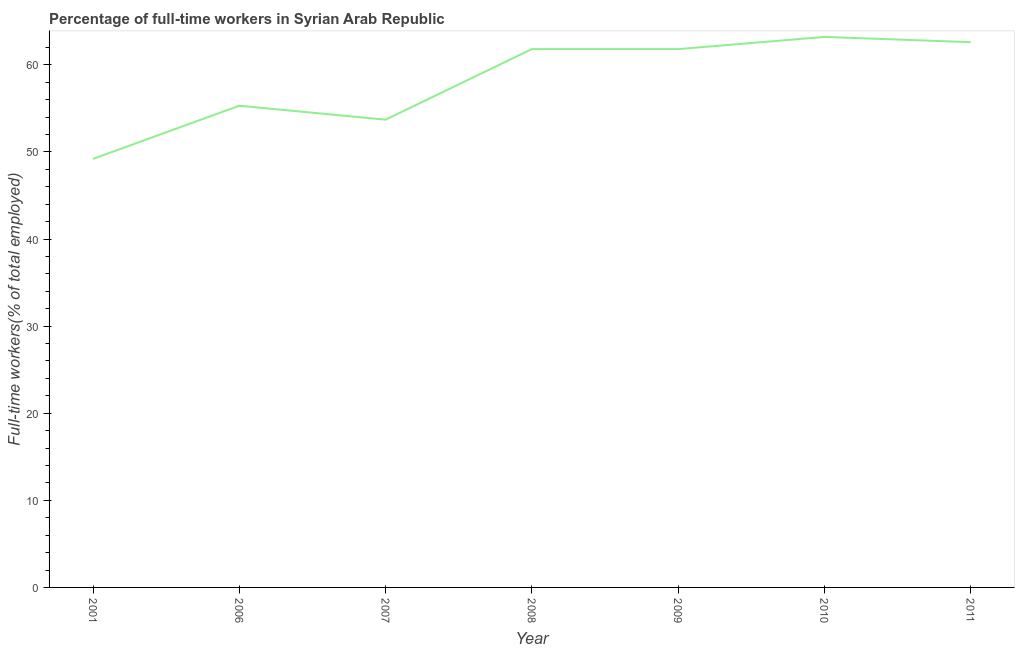What is the percentage of full-time workers in 2006?
Your response must be concise. 55.3. Across all years, what is the maximum percentage of full-time workers?
Your answer should be very brief. 63.2. Across all years, what is the minimum percentage of full-time workers?
Your response must be concise. 49.2. What is the sum of the percentage of full-time workers?
Make the answer very short. 407.6. What is the average percentage of full-time workers per year?
Ensure brevity in your answer.  58.23. What is the median percentage of full-time workers?
Offer a terse response. 61.8. Do a majority of the years between 2010 and 2011 (inclusive) have percentage of full-time workers greater than 22 %?
Keep it short and to the point. Yes. What is the ratio of the percentage of full-time workers in 2001 to that in 2006?
Provide a succinct answer. 0.89. Is the percentage of full-time workers in 2001 less than that in 2010?
Offer a very short reply. Yes. What is the difference between the highest and the second highest percentage of full-time workers?
Give a very brief answer. 0.6. How many years are there in the graph?
Provide a short and direct response. 7. What is the title of the graph?
Make the answer very short. Percentage of full-time workers in Syrian Arab Republic. What is the label or title of the Y-axis?
Offer a very short reply. Full-time workers(% of total employed). What is the Full-time workers(% of total employed) in 2001?
Offer a terse response. 49.2. What is the Full-time workers(% of total employed) of 2006?
Provide a succinct answer. 55.3. What is the Full-time workers(% of total employed) of 2007?
Give a very brief answer. 53.7. What is the Full-time workers(% of total employed) of 2008?
Your response must be concise. 61.8. What is the Full-time workers(% of total employed) of 2009?
Ensure brevity in your answer.  61.8. What is the Full-time workers(% of total employed) of 2010?
Offer a very short reply. 63.2. What is the Full-time workers(% of total employed) in 2011?
Give a very brief answer. 62.6. What is the difference between the Full-time workers(% of total employed) in 2006 and 2009?
Provide a succinct answer. -6.5. What is the difference between the Full-time workers(% of total employed) in 2006 and 2010?
Your answer should be compact. -7.9. What is the difference between the Full-time workers(% of total employed) in 2006 and 2011?
Your answer should be very brief. -7.3. What is the difference between the Full-time workers(% of total employed) in 2007 and 2008?
Your answer should be very brief. -8.1. What is the difference between the Full-time workers(% of total employed) in 2007 and 2009?
Your answer should be compact. -8.1. What is the difference between the Full-time workers(% of total employed) in 2007 and 2011?
Your answer should be very brief. -8.9. What is the difference between the Full-time workers(% of total employed) in 2009 and 2010?
Ensure brevity in your answer.  -1.4. What is the difference between the Full-time workers(% of total employed) in 2010 and 2011?
Give a very brief answer. 0.6. What is the ratio of the Full-time workers(% of total employed) in 2001 to that in 2006?
Your answer should be compact. 0.89. What is the ratio of the Full-time workers(% of total employed) in 2001 to that in 2007?
Your answer should be compact. 0.92. What is the ratio of the Full-time workers(% of total employed) in 2001 to that in 2008?
Ensure brevity in your answer.  0.8. What is the ratio of the Full-time workers(% of total employed) in 2001 to that in 2009?
Provide a short and direct response. 0.8. What is the ratio of the Full-time workers(% of total employed) in 2001 to that in 2010?
Offer a terse response. 0.78. What is the ratio of the Full-time workers(% of total employed) in 2001 to that in 2011?
Your response must be concise. 0.79. What is the ratio of the Full-time workers(% of total employed) in 2006 to that in 2008?
Provide a succinct answer. 0.9. What is the ratio of the Full-time workers(% of total employed) in 2006 to that in 2009?
Make the answer very short. 0.9. What is the ratio of the Full-time workers(% of total employed) in 2006 to that in 2011?
Your response must be concise. 0.88. What is the ratio of the Full-time workers(% of total employed) in 2007 to that in 2008?
Your answer should be very brief. 0.87. What is the ratio of the Full-time workers(% of total employed) in 2007 to that in 2009?
Keep it short and to the point. 0.87. What is the ratio of the Full-time workers(% of total employed) in 2007 to that in 2011?
Your response must be concise. 0.86. What is the ratio of the Full-time workers(% of total employed) in 2008 to that in 2011?
Provide a short and direct response. 0.99. What is the ratio of the Full-time workers(% of total employed) in 2009 to that in 2010?
Offer a very short reply. 0.98. What is the ratio of the Full-time workers(% of total employed) in 2009 to that in 2011?
Provide a short and direct response. 0.99. What is the ratio of the Full-time workers(% of total employed) in 2010 to that in 2011?
Offer a terse response. 1.01. 